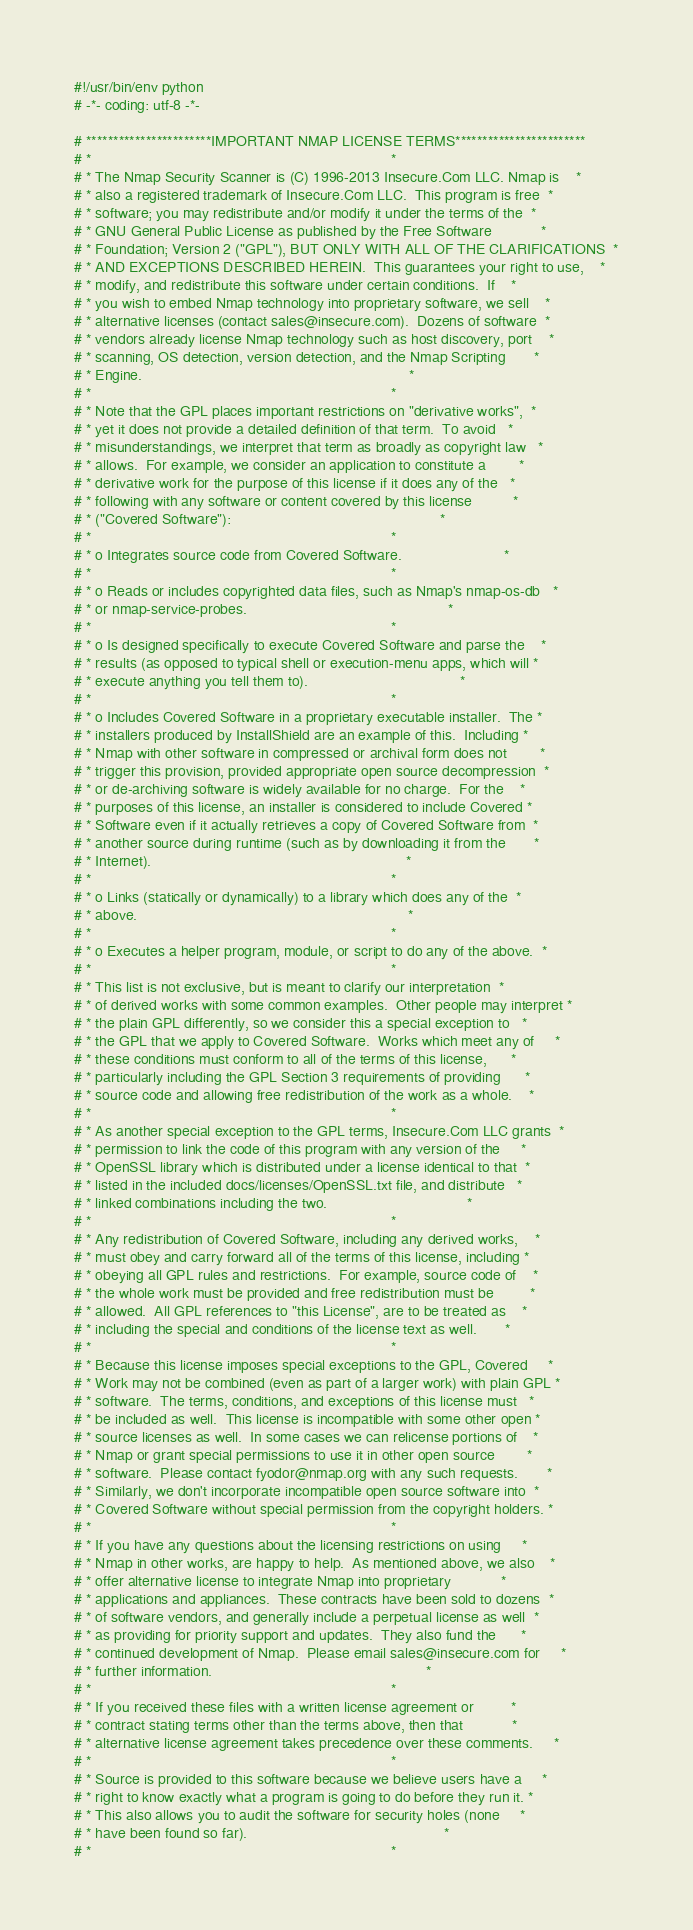Convert code to text. <code><loc_0><loc_0><loc_500><loc_500><_Python_>#!/usr/bin/env python
# -*- coding: utf-8 -*-

# ***********************IMPORTANT NMAP LICENSE TERMS************************
# *                                                                         *
# * The Nmap Security Scanner is (C) 1996-2013 Insecure.Com LLC. Nmap is    *
# * also a registered trademark of Insecure.Com LLC.  This program is free  *
# * software; you may redistribute and/or modify it under the terms of the  *
# * GNU General Public License as published by the Free Software            *
# * Foundation; Version 2 ("GPL"), BUT ONLY WITH ALL OF THE CLARIFICATIONS  *
# * AND EXCEPTIONS DESCRIBED HEREIN.  This guarantees your right to use,    *
# * modify, and redistribute this software under certain conditions.  If    *
# * you wish to embed Nmap technology into proprietary software, we sell    *
# * alternative licenses (contact sales@insecure.com).  Dozens of software  *
# * vendors already license Nmap technology such as host discovery, port    *
# * scanning, OS detection, version detection, and the Nmap Scripting       *
# * Engine.                                                                 *
# *                                                                         *
# * Note that the GPL places important restrictions on "derivative works",  *
# * yet it does not provide a detailed definition of that term.  To avoid   *
# * misunderstandings, we interpret that term as broadly as copyright law   *
# * allows.  For example, we consider an application to constitute a        *
# * derivative work for the purpose of this license if it does any of the   *
# * following with any software or content covered by this license          *
# * ("Covered Software"):                                                   *
# *                                                                         *
# * o Integrates source code from Covered Software.                         *
# *                                                                         *
# * o Reads or includes copyrighted data files, such as Nmap's nmap-os-db   *
# * or nmap-service-probes.                                                 *
# *                                                                         *
# * o Is designed specifically to execute Covered Software and parse the    *
# * results (as opposed to typical shell or execution-menu apps, which will *
# * execute anything you tell them to).                                     *
# *                                                                         *
# * o Includes Covered Software in a proprietary executable installer.  The *
# * installers produced by InstallShield are an example of this.  Including *
# * Nmap with other software in compressed or archival form does not        *
# * trigger this provision, provided appropriate open source decompression  *
# * or de-archiving software is widely available for no charge.  For the    *
# * purposes of this license, an installer is considered to include Covered *
# * Software even if it actually retrieves a copy of Covered Software from  *
# * another source during runtime (such as by downloading it from the       *
# * Internet).                                                              *
# *                                                                         *
# * o Links (statically or dynamically) to a library which does any of the  *
# * above.                                                                  *
# *                                                                         *
# * o Executes a helper program, module, or script to do any of the above.  *
# *                                                                         *
# * This list is not exclusive, but is meant to clarify our interpretation  *
# * of derived works with some common examples.  Other people may interpret *
# * the plain GPL differently, so we consider this a special exception to   *
# * the GPL that we apply to Covered Software.  Works which meet any of     *
# * these conditions must conform to all of the terms of this license,      *
# * particularly including the GPL Section 3 requirements of providing      *
# * source code and allowing free redistribution of the work as a whole.    *
# *                                                                         *
# * As another special exception to the GPL terms, Insecure.Com LLC grants  *
# * permission to link the code of this program with any version of the     *
# * OpenSSL library which is distributed under a license identical to that  *
# * listed in the included docs/licenses/OpenSSL.txt file, and distribute   *
# * linked combinations including the two.                                  *
# *                                                                         *
# * Any redistribution of Covered Software, including any derived works,    *
# * must obey and carry forward all of the terms of this license, including *
# * obeying all GPL rules and restrictions.  For example, source code of    *
# * the whole work must be provided and free redistribution must be         *
# * allowed.  All GPL references to "this License", are to be treated as    *
# * including the special and conditions of the license text as well.       *
# *                                                                         *
# * Because this license imposes special exceptions to the GPL, Covered     *
# * Work may not be combined (even as part of a larger work) with plain GPL *
# * software.  The terms, conditions, and exceptions of this license must   *
# * be included as well.  This license is incompatible with some other open *
# * source licenses as well.  In some cases we can relicense portions of    *
# * Nmap or grant special permissions to use it in other open source        *
# * software.  Please contact fyodor@nmap.org with any such requests.       *
# * Similarly, we don't incorporate incompatible open source software into  *
# * Covered Software without special permission from the copyright holders. *
# *                                                                         *
# * If you have any questions about the licensing restrictions on using     *
# * Nmap in other works, are happy to help.  As mentioned above, we also    *
# * offer alternative license to integrate Nmap into proprietary            *
# * applications and appliances.  These contracts have been sold to dozens  *
# * of software vendors, and generally include a perpetual license as well  *
# * as providing for priority support and updates.  They also fund the      *
# * continued development of Nmap.  Please email sales@insecure.com for     *
# * further information.                                                    *
# *                                                                         *
# * If you received these files with a written license agreement or         *
# * contract stating terms other than the terms above, then that            *
# * alternative license agreement takes precedence over these comments.     *
# *                                                                         *
# * Source is provided to this software because we believe users have a     *
# * right to know exactly what a program is going to do before they run it. *
# * This also allows you to audit the software for security holes (none     *
# * have been found so far).                                                *
# *                                                                         *</code> 